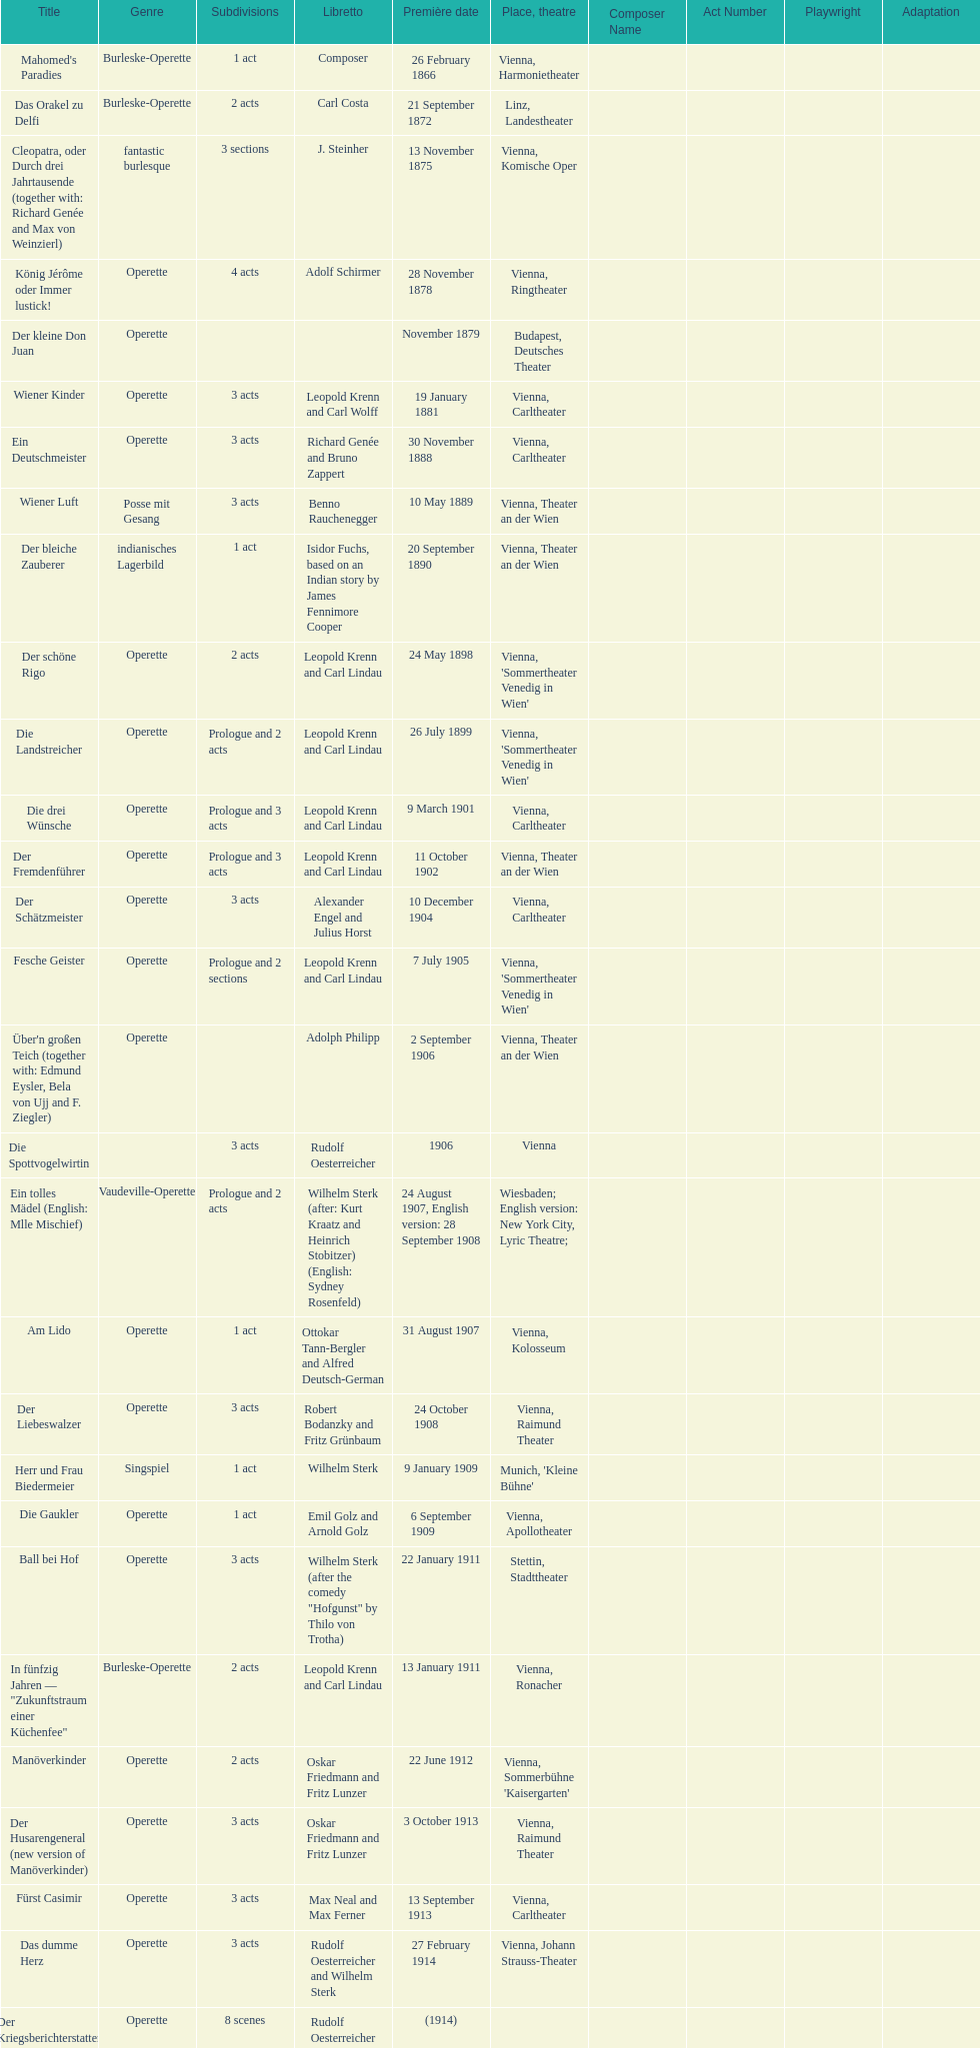Up to which year do all the dates go? 1958. 